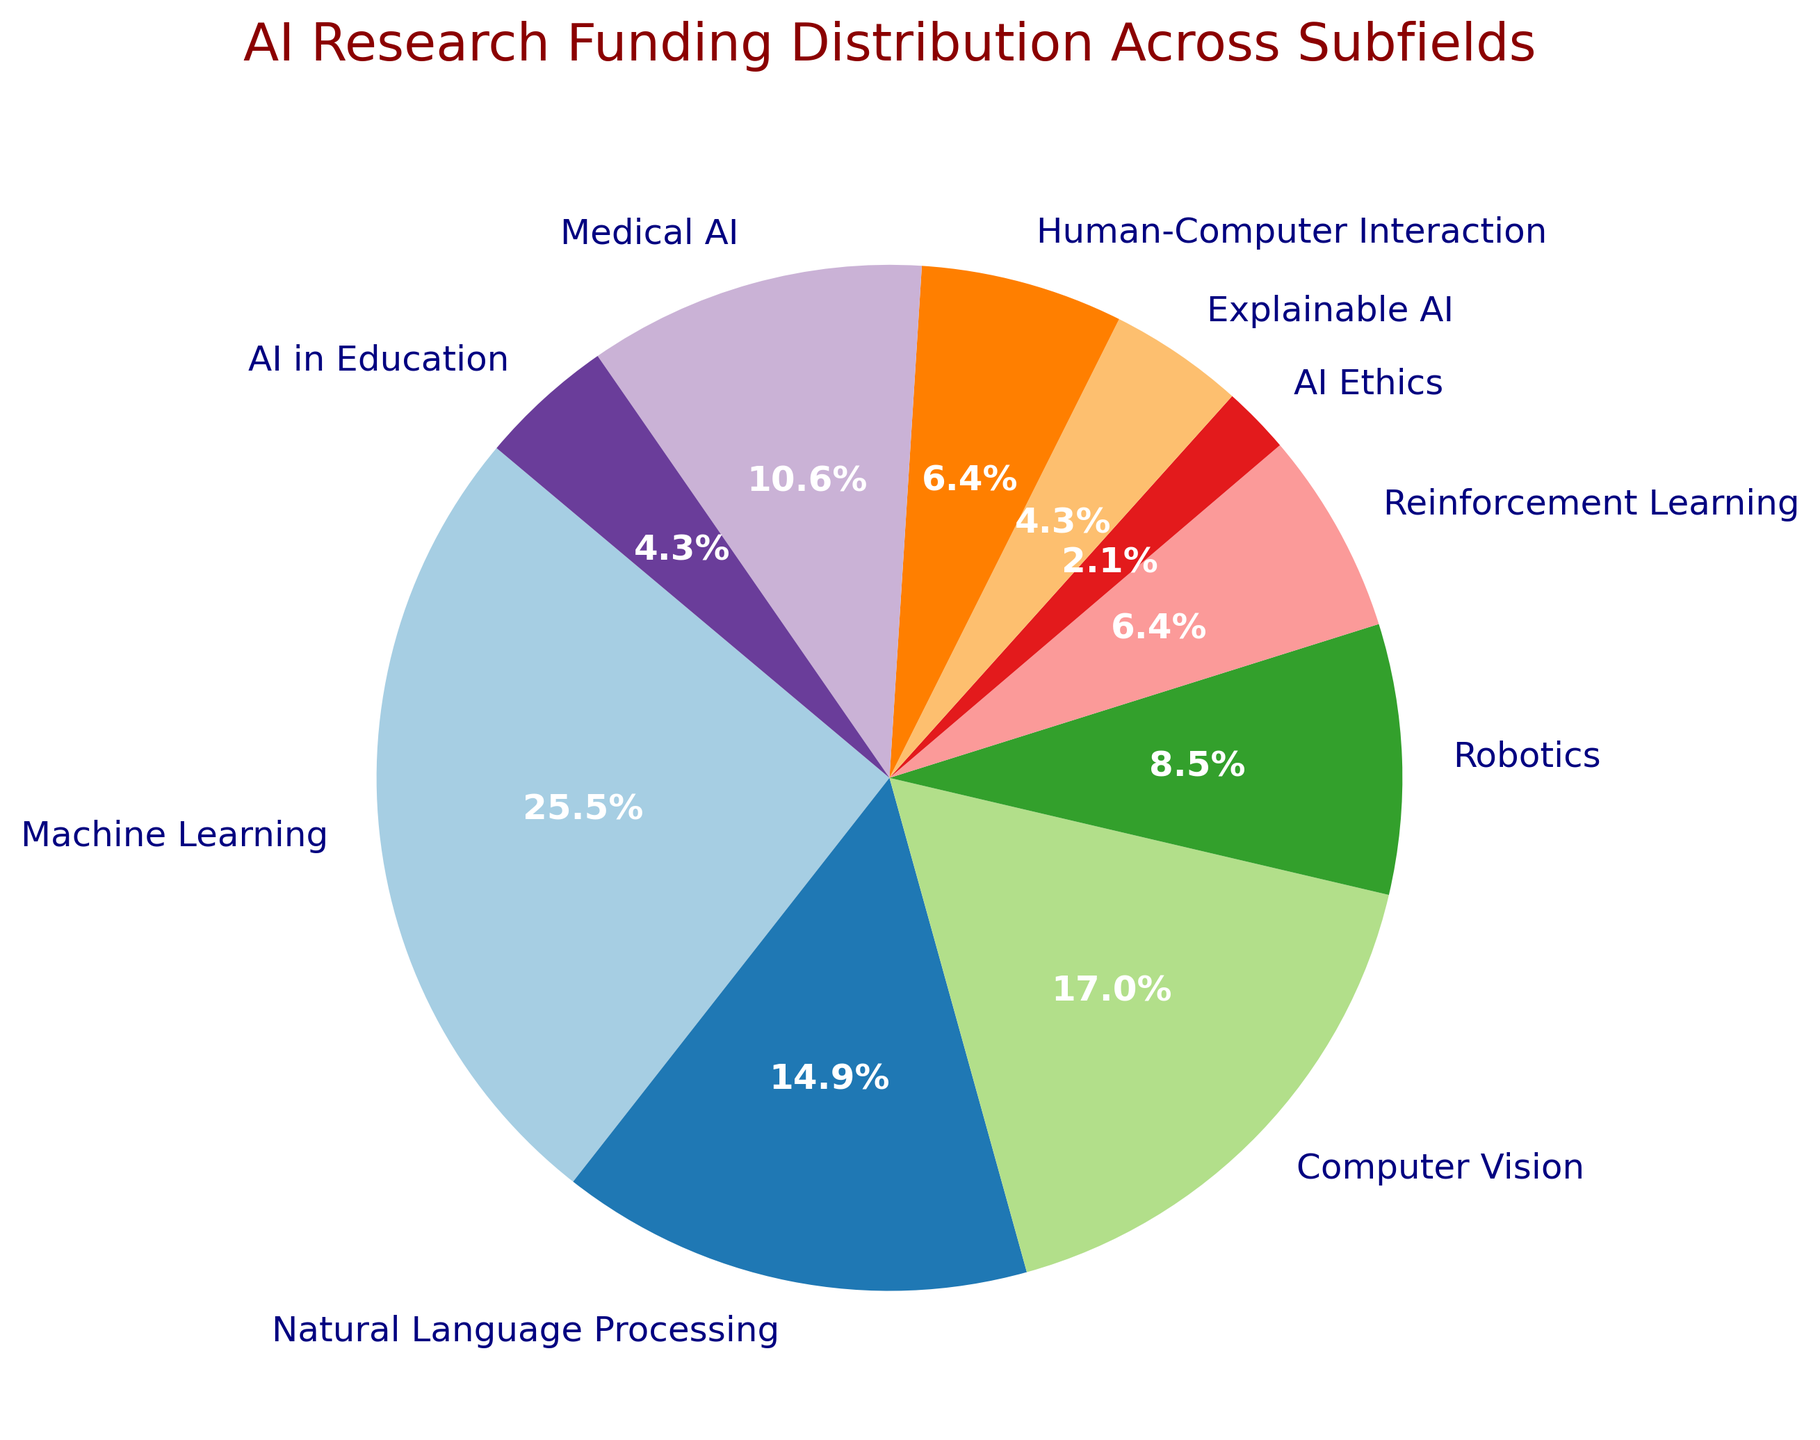What is the largest funding subfield in AI research? According to the pie chart representing AI research funding distribution, the segment for Machine Learning occupies the largest portion.
Answer: Machine Learning Which AI subfield receives the least funding? Observing the pie chart, the segment for AI Ethics is the smallest, indicating it receives the least funding.
Answer: AI Ethics How much more funding does Computer Vision receive compared to AI Ethics? The funding for Computer Vision is $400 million, and for AI Ethics, it is $50 million. The difference is $400 million - $50 million.
Answer: $350 million What percentage of the total funding does Natural Language Processing receive? On the pie chart, the segment for Natural Language Processing has a label indicating that it receives 20.1% of the total funding.
Answer: 20.1% Which subfield receives more funding: Robotics or Human-Computer Interaction? By comparing the respective segments in the pie chart, Robotics receives $200 million, whereas Human-Computer Interaction receives $150 million. Therefore, Robotics receives more funding.
Answer: Robotics What is the combined funding percentage for Explainable AI and AI in Education? On the pie chart, Explainable AI is labeled with 8.1%, and AI in Education with 7.2%. Adding them together gives a combined funding percentage of 8.1% + 7.2%.
Answer: 15.3% Is the funding for Medical AI greater than the total funding for Reinforcement Learning and AI in Education combined? Medical AI funding is $250 million. The combined funding for Reinforcement Learning and AI in Education is $150 million + $100 million, which equals $250 million. Thus, Medical AI funding is not greater.
Answer: No Which AI subfields have a funding amount closest to $200 million? From the pie chart, Robotics and Human-Computer Interaction each receive $200 million in funding.
Answer: Robotics, Human-Computer Interaction What is the total funding percentage for subfields other than Machine Learning and Natural Language Processing? Adding the other subfields: Computer Vision (22.9%), Robotics (11.4%), Reinforcement Learning (8.6%), AI Ethics (2.9%), Explainable AI (5.7%), Human-Computer Interaction (8.6%), Medical AI (14.3%), and AI in Education (5.7%), gives the total: 22.9% + 11.4% + 8.6% + 2.9% + 5.7% + 8.6% + 14.3% + 5.7% = 80.1%.
Answer: 80.1% Does Machine Learning receive more funding than the combined amount for Natural Language Processing and Medical AI? Machine Learning receives $600 million. The combined amount for Natural Language Processing ($350 million) and Medical AI ($250 million) is $350 million + $250 million = $600 million. So Machine Learning does not receive more funding.
Answer: No 